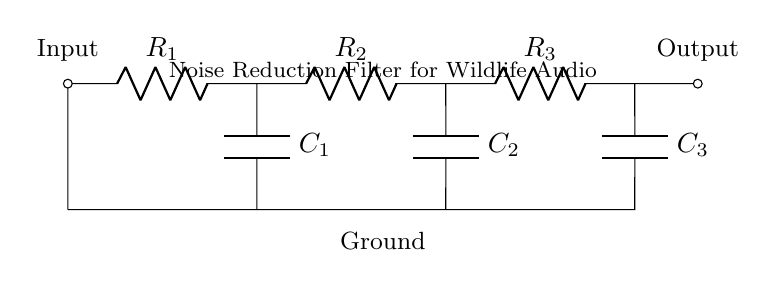What is the input of this circuit? The input is the point where the signal enters the circuit, indicated by the label "Input" at the top left corner.
Answer: Input How many resistors are in this filter circuit? There are three resistors present, labeled R1, R2, and R3, as shown in the diagram.
Answer: Three What is the purpose of the capacitors in this circuit? The capacitors, C1, C2, and C3, serve to filter out noise by blocking certain frequencies while allowing others to pass, which is fundamental in noise reduction.
Answer: Noise filtering Which component connects to the output? The output is connected by the last resistor R3, which leads to the output point labeled at the top right corner of the circuit.
Answer: R3 What type of filter is this circuit designed for? This circuit is designed as a noise reduction filter specifically for audio recordings, as indicated in the title of the diagram.
Answer: Noise reduction filter How does the signal flow through this filter circuit? The signal flows from the left input through resistors and capacitors in series, eventually reaching the output on the right side, illustrating a sequential processing of the signal.
Answer: Left to right 